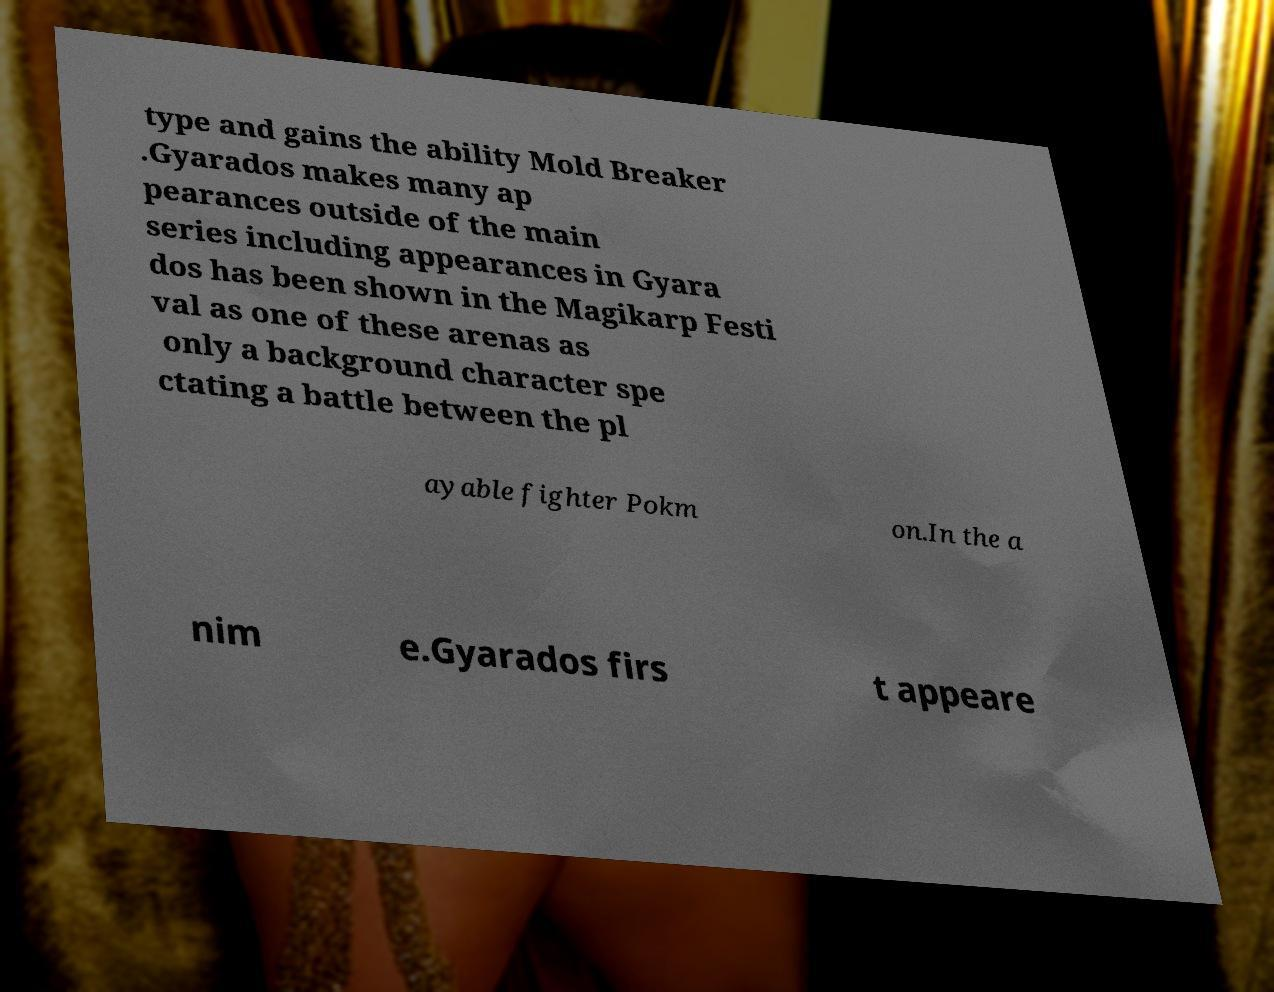For documentation purposes, I need the text within this image transcribed. Could you provide that? type and gains the ability Mold Breaker .Gyarados makes many ap pearances outside of the main series including appearances in Gyara dos has been shown in the Magikarp Festi val as one of these arenas as only a background character spe ctating a battle between the pl ayable fighter Pokm on.In the a nim e.Gyarados firs t appeare 